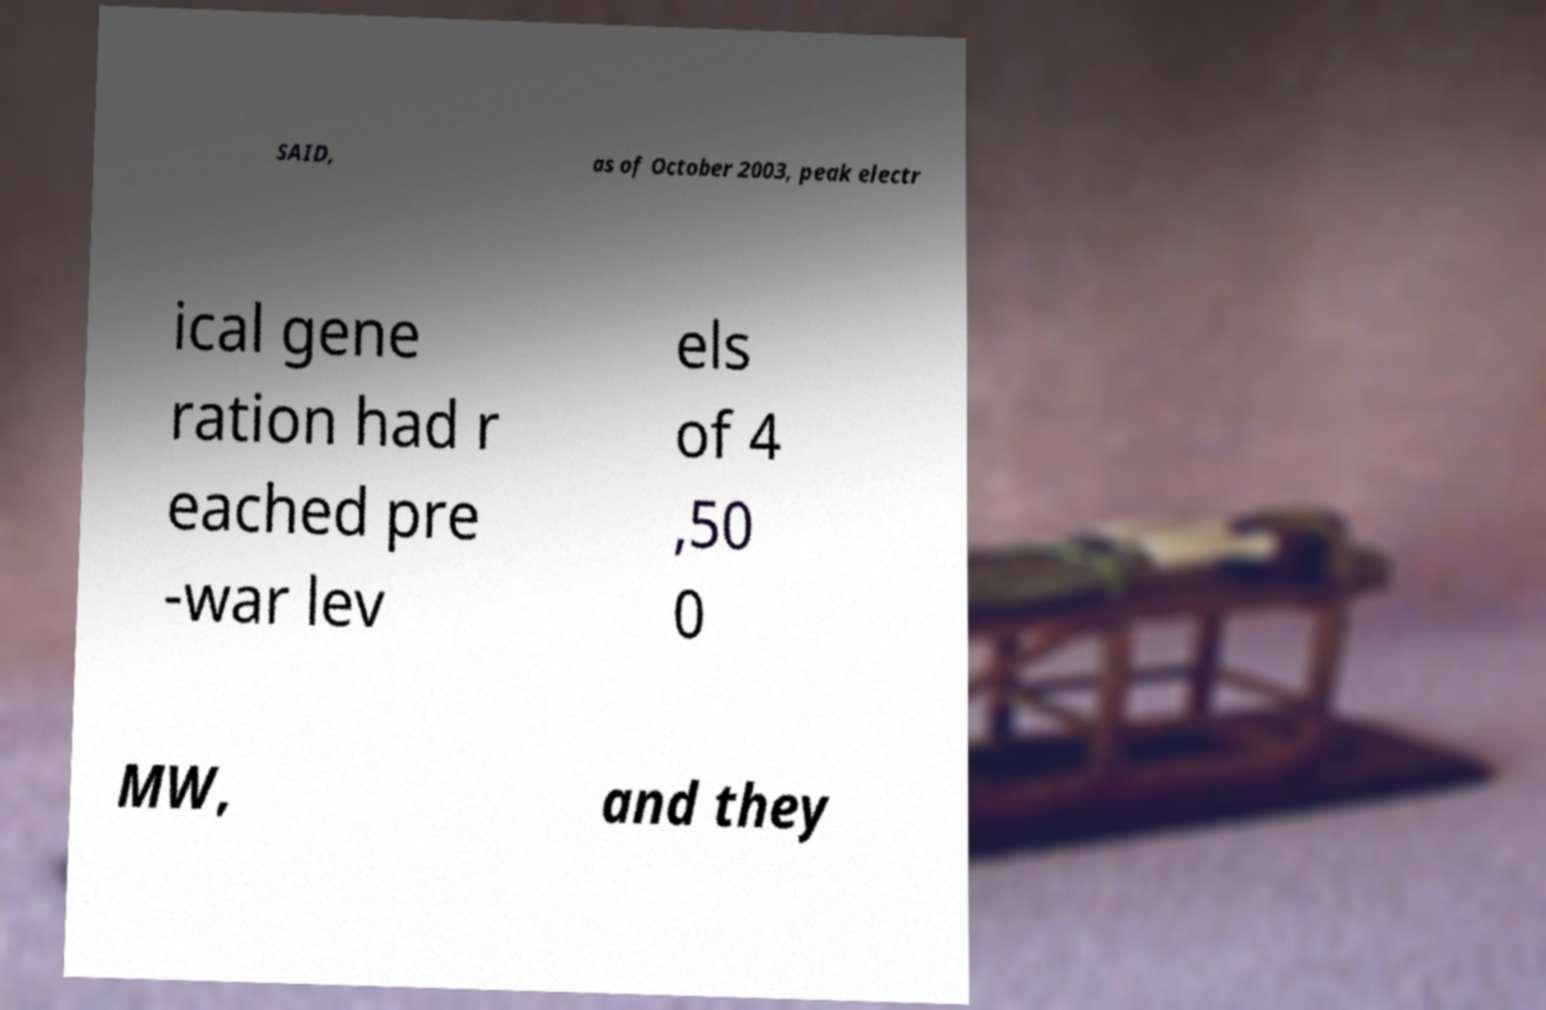Please read and relay the text visible in this image. What does it say? SAID, as of October 2003, peak electr ical gene ration had r eached pre -war lev els of 4 ,50 0 MW, and they 